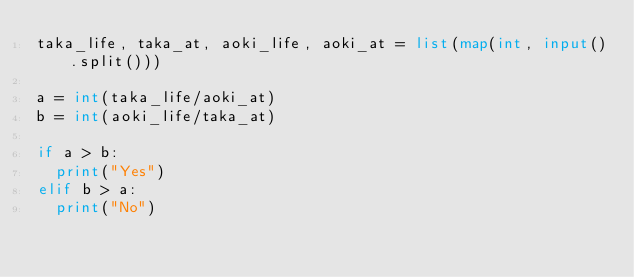Convert code to text. <code><loc_0><loc_0><loc_500><loc_500><_Python_>taka_life, taka_at, aoki_life, aoki_at = list(map(int, input().split())) 

a = int(taka_life/aoki_at)
b = int(aoki_life/taka_at)

if a > b:
  print("Yes")
elif b > a:
  print("No")</code> 